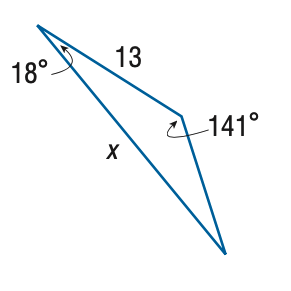Answer the mathemtical geometry problem and directly provide the correct option letter.
Question: Find x. Round the side measure to the nearest tenth.
Choices: A: 6.4 B: 7.4 C: 22.8 D: 26.5 C 